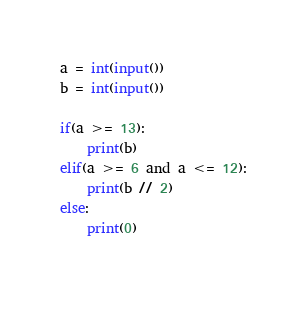<code> <loc_0><loc_0><loc_500><loc_500><_Python_>a = int(input())
b = int(input())

if(a >= 13):
    print(b)
elif(a >= 6 and a <= 12):
    print(b // 2)
else:
    print(0)
    </code> 